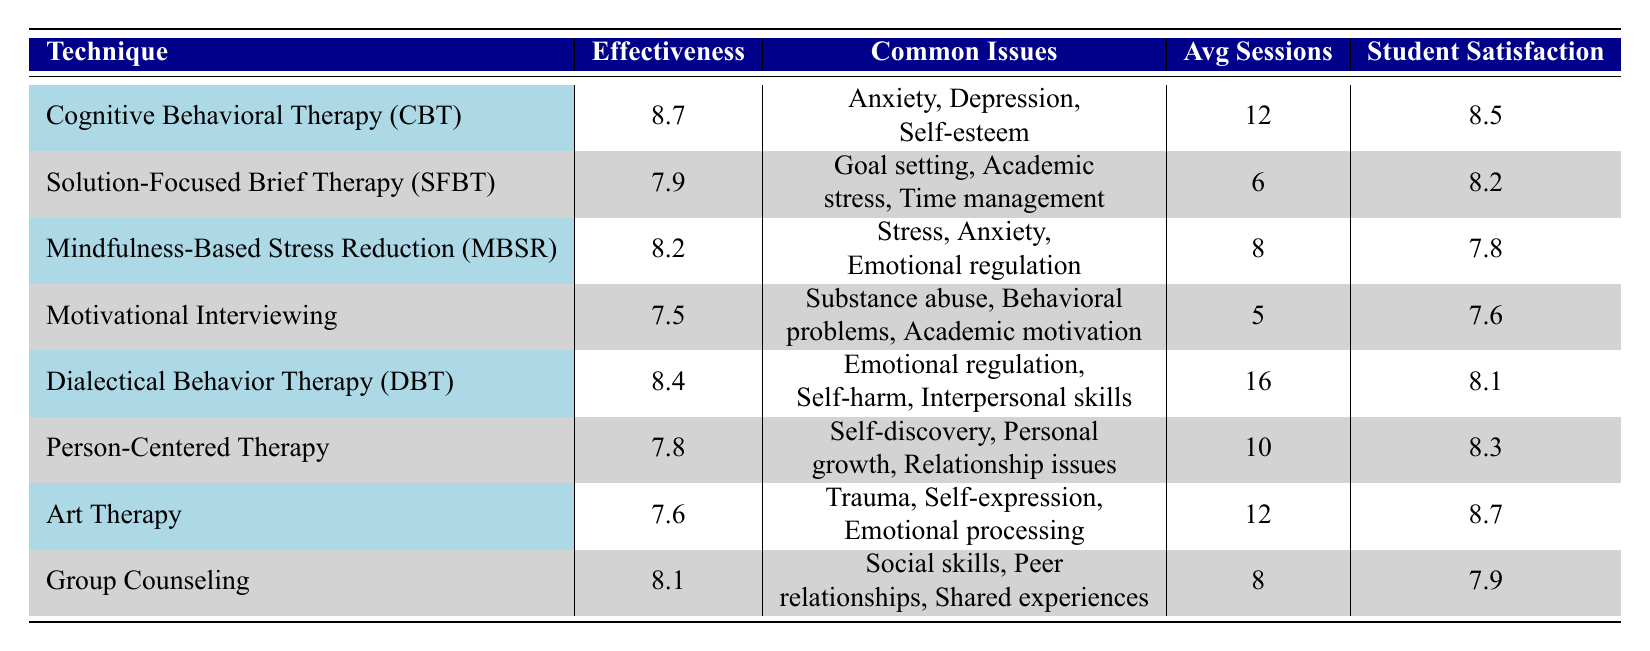What is the effectiveness rating of Cognitive Behavioral Therapy (CBT)? The effectiveness rating for CBT is explicitly listed in the table.
Answer: 8.7 Which counseling technique has the highest student satisfaction? By comparing the student satisfaction values in the table, CBT has a satisfaction rating of 8.5, and Art Therapy has 8.7, which is the highest.
Answer: Art Therapy What is the average number of sessions required for Solution-Focused Brief Therapy (SFBT)? The average number of sessions for SFBT is provided directly in the table.
Answer: 6 Is Dialectical Behavior Therapy (DBT) effective in addressing self-harm? Self-harm is mentioned in the common issues addressed for DBT in the table, confirming its focus on this issue.
Answer: Yes What is the difference in effectiveness ratings between Mindfulness-Based Stress Reduction (MBSR) and Motivational Interviewing? The effectiveness rating for MBSR is 8.2, and for Motivational Interviewing, it is 7.5. The difference is calculated as 8.2 - 7.5 = 0.7.
Answer: 0.7 Which counseling technique requires the fewest average sessions? By reviewing the table, Motivational Interviewing has the lowest average sessions required at 5.
Answer: 5 What is the average student satisfaction rating across all counseling techniques? We sum the student satisfaction ratings (8.5 + 8.2 + 7.8 + 7.6 + 8.4 + 8.3 + 8.7 + 7.9 = 57.4) and divide by the number of techniques (8), yielding an average of 57.4/8 = 7.175.
Answer: 7.175 Does every technique have an effectiveness rating above 7? Verifying the effectiveness ratings in the table, all techniques listed have ratings above 7 except for Motivational Interviewing (7.5) and Art Therapy (7.6), confirming that not all are above 7.
Answer: No How many more sessions does Dialectical Behavior Therapy (DBT) require compared to Solution-Focused Brief Therapy (SFBT)? The average sessions for DBT is 16 and for SFBT is 6. Therefore, the difference is 16 - 6 = 10.
Answer: 10 Is Cognitive Behavioral Therapy (CBT) the most effective technique based on the effectiveness ratings? CBT has an effectiveness rating of 8.7, which is the highest among all techniques listed in the table.
Answer: Yes 